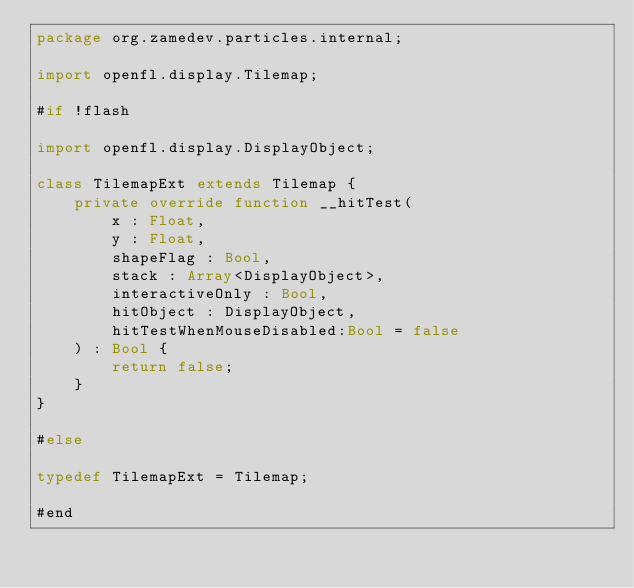<code> <loc_0><loc_0><loc_500><loc_500><_Haxe_>package org.zamedev.particles.internal;

import openfl.display.Tilemap;

#if !flash

import openfl.display.DisplayObject;

class TilemapExt extends Tilemap {
    private override function __hitTest(
        x : Float,
        y : Float,
        shapeFlag : Bool,
        stack : Array<DisplayObject>,
        interactiveOnly : Bool,
        hitObject : DisplayObject,
        hitTestWhenMouseDisabled:Bool = false
    ) : Bool {
        return false;
    }
}

#else

typedef TilemapExt = Tilemap;

#end
</code> 